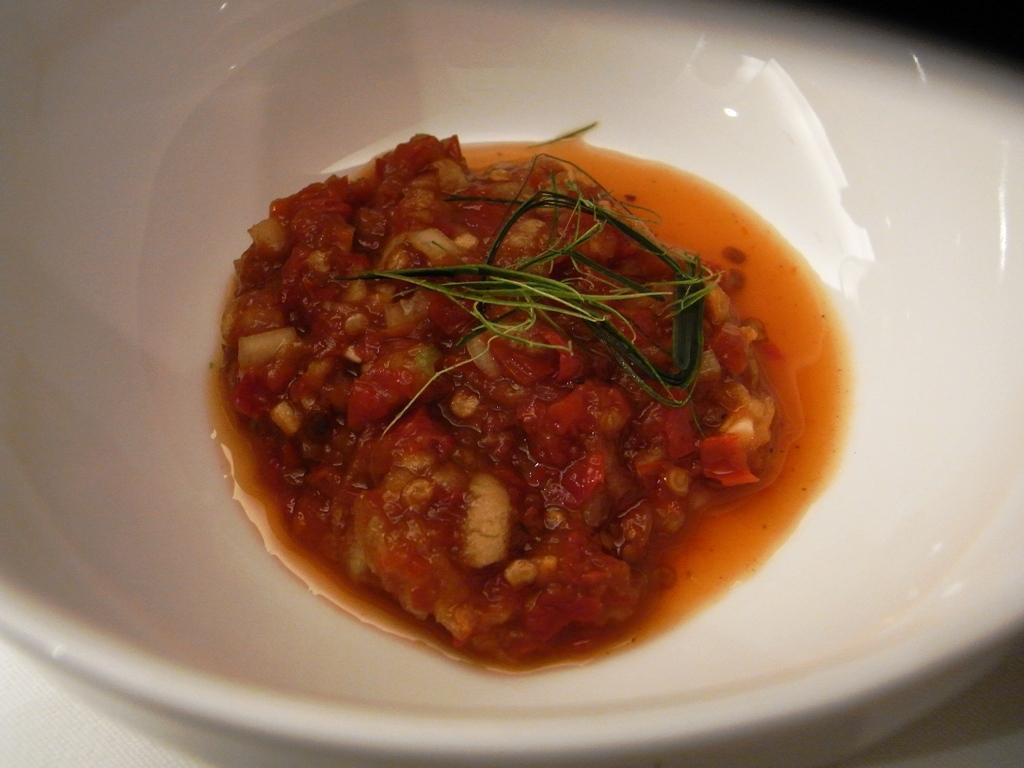What color is the bowl that is visible in the image? The bowl is white. What is inside the bowl in the image? The bowl is filled with food items. What type of flag is being used to mix the paste in the image? There is no flag or paste present in the image; it only features a white bowl filled with food items. 